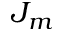Convert formula to latex. <formula><loc_0><loc_0><loc_500><loc_500>J _ { m }</formula> 